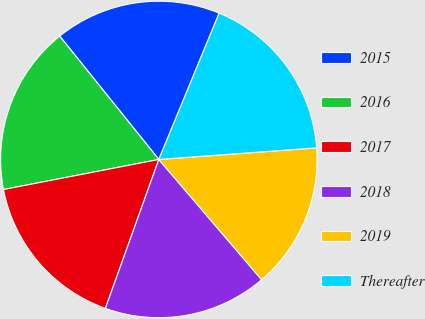Convert chart. <chart><loc_0><loc_0><loc_500><loc_500><pie_chart><fcel>2015 � � � � � � � � � � � � �<fcel>2016 � � � � � � � � � � � � �<fcel>2017 � � � � � � � � � � � � �<fcel>2018 � � � � � � � � � � � � �<fcel>2019 � � � � � � � � � � � � �<fcel>Thereafter � � � � � � � � � �<nl><fcel>17.0%<fcel>17.27%<fcel>16.47%<fcel>16.74%<fcel>14.91%<fcel>17.61%<nl></chart> 